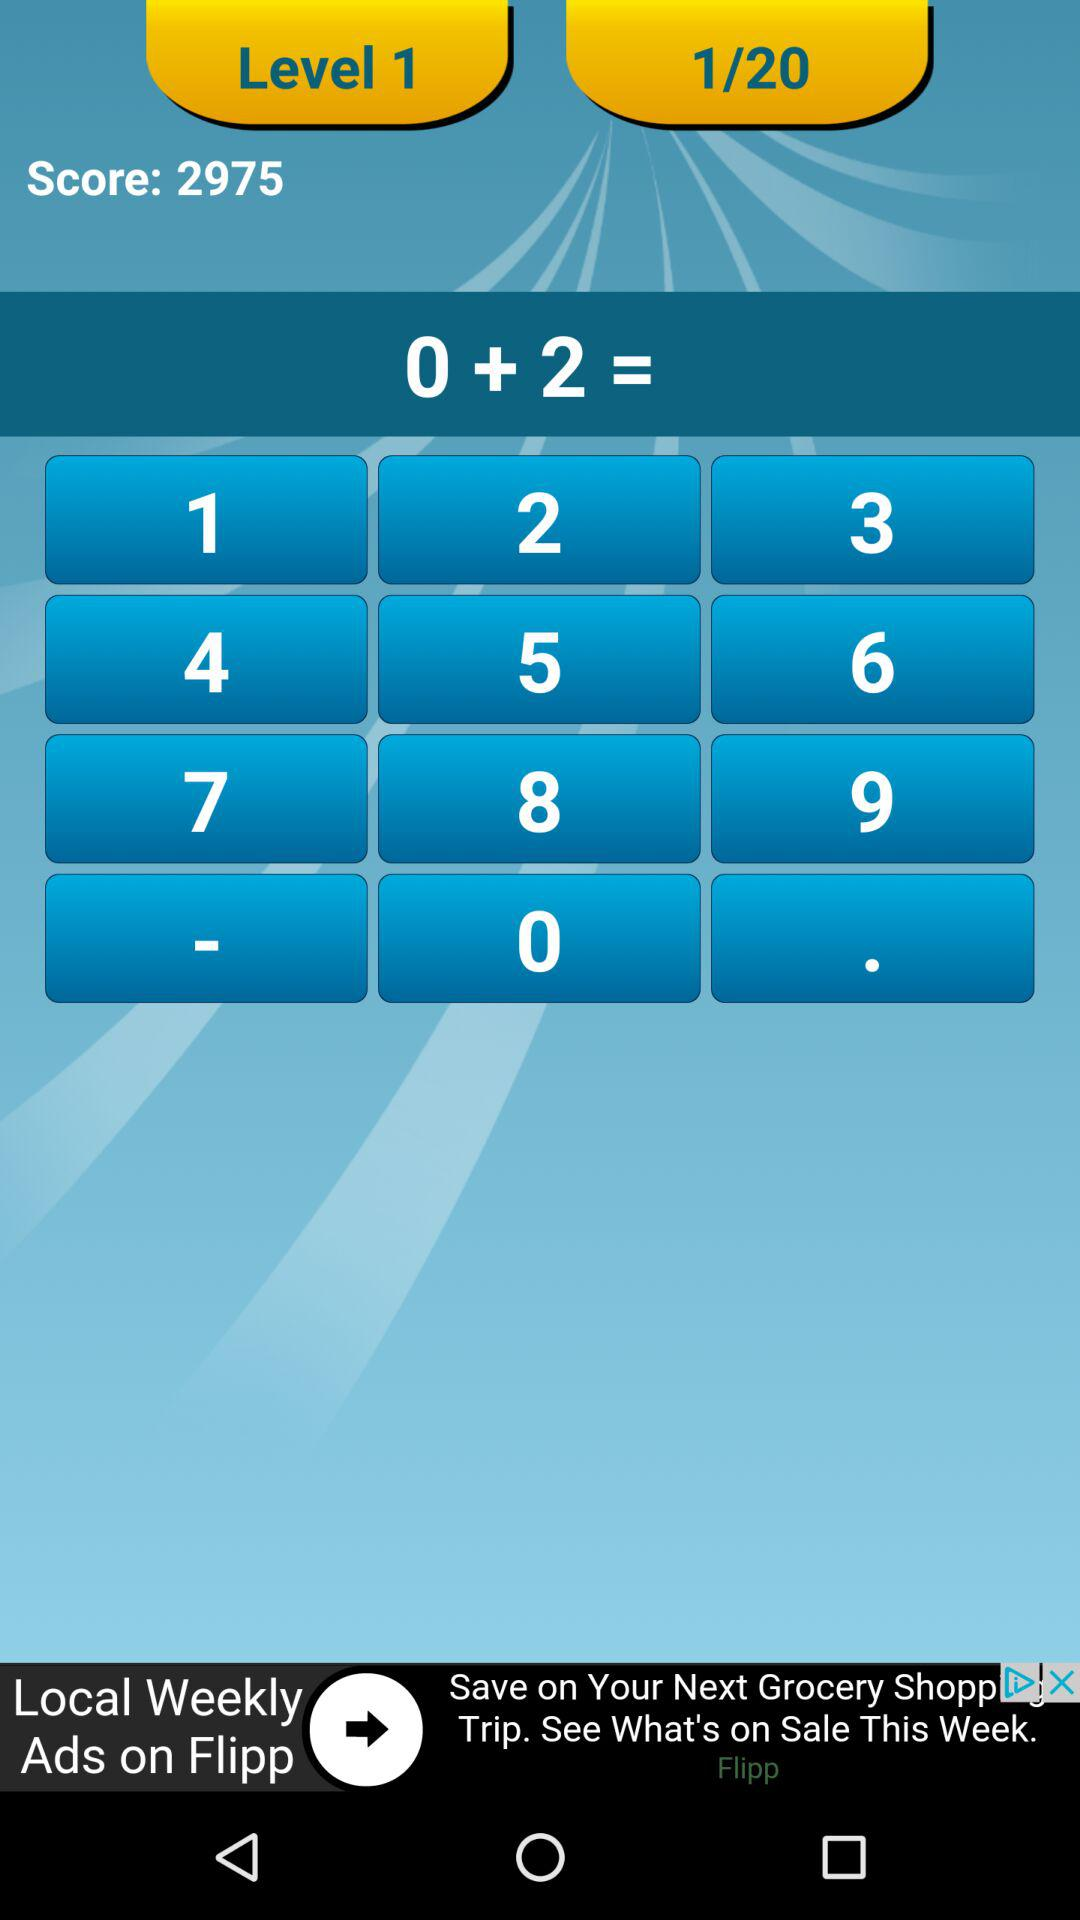What is the score? The score is 2975. 